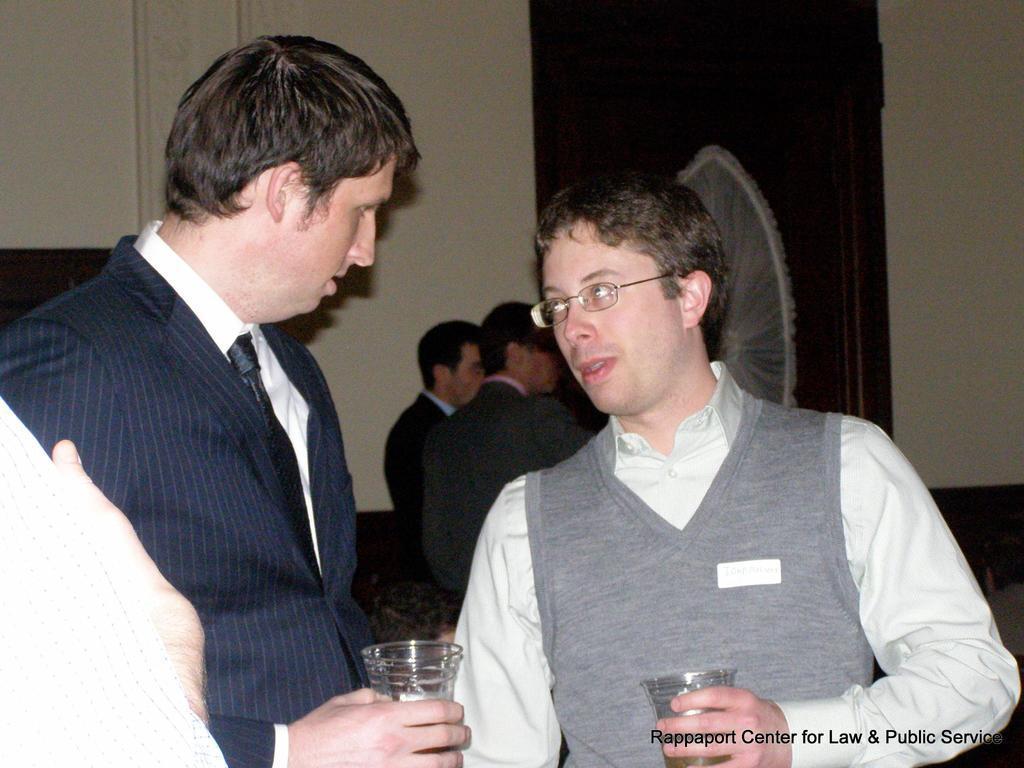Could you give a brief overview of what you see in this image? In this image we can see this person wearing a blazer and tie and this person wearing shirt, jacket and spectacles, are holding glasses with drinks in it in their hands. In the background, we can see a few more people wearing blazers are standing and we can see the wall. Here we can see some text on the bottom right side of the image. 